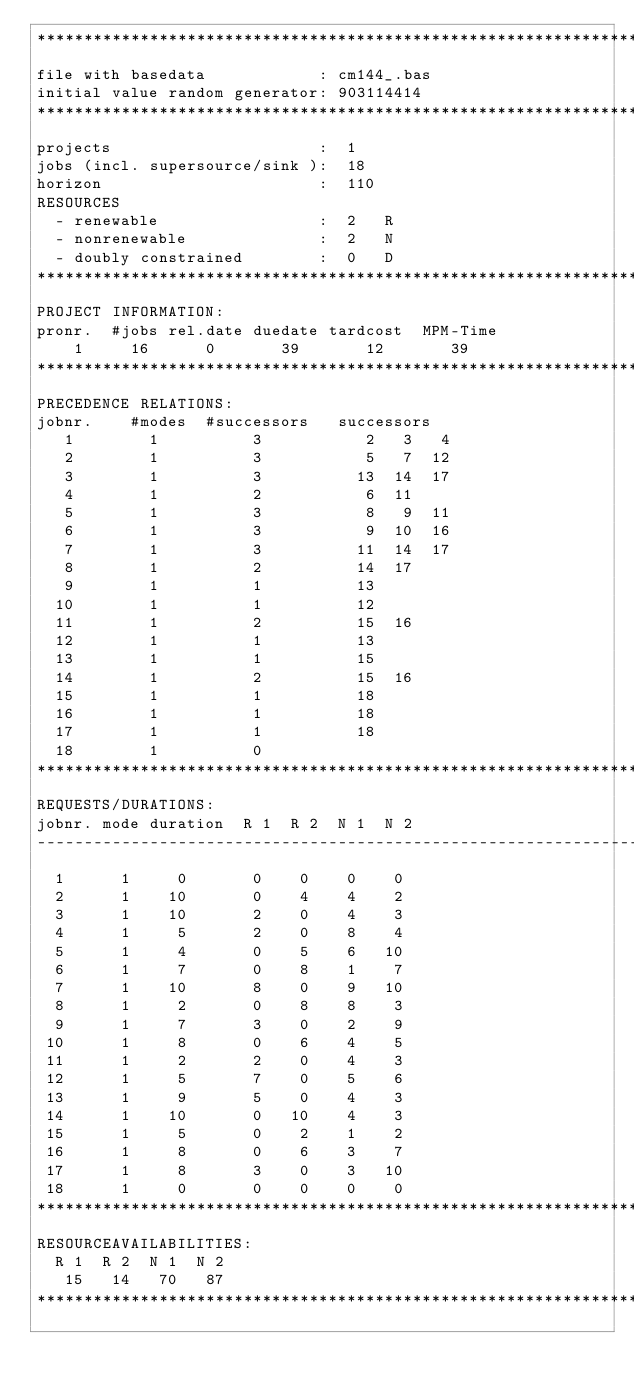<code> <loc_0><loc_0><loc_500><loc_500><_ObjectiveC_>************************************************************************
file with basedata            : cm144_.bas
initial value random generator: 903114414
************************************************************************
projects                      :  1
jobs (incl. supersource/sink ):  18
horizon                       :  110
RESOURCES
  - renewable                 :  2   R
  - nonrenewable              :  2   N
  - doubly constrained        :  0   D
************************************************************************
PROJECT INFORMATION:
pronr.  #jobs rel.date duedate tardcost  MPM-Time
    1     16      0       39       12       39
************************************************************************
PRECEDENCE RELATIONS:
jobnr.    #modes  #successors   successors
   1        1          3           2   3   4
   2        1          3           5   7  12
   3        1          3          13  14  17
   4        1          2           6  11
   5        1          3           8   9  11
   6        1          3           9  10  16
   7        1          3          11  14  17
   8        1          2          14  17
   9        1          1          13
  10        1          1          12
  11        1          2          15  16
  12        1          1          13
  13        1          1          15
  14        1          2          15  16
  15        1          1          18
  16        1          1          18
  17        1          1          18
  18        1          0        
************************************************************************
REQUESTS/DURATIONS:
jobnr. mode duration  R 1  R 2  N 1  N 2
------------------------------------------------------------------------
  1      1     0       0    0    0    0
  2      1    10       0    4    4    2
  3      1    10       2    0    4    3
  4      1     5       2    0    8    4
  5      1     4       0    5    6   10
  6      1     7       0    8    1    7
  7      1    10       8    0    9   10
  8      1     2       0    8    8    3
  9      1     7       3    0    2    9
 10      1     8       0    6    4    5
 11      1     2       2    0    4    3
 12      1     5       7    0    5    6
 13      1     9       5    0    4    3
 14      1    10       0   10    4    3
 15      1     5       0    2    1    2
 16      1     8       0    6    3    7
 17      1     8       3    0    3   10
 18      1     0       0    0    0    0
************************************************************************
RESOURCEAVAILABILITIES:
  R 1  R 2  N 1  N 2
   15   14   70   87
************************************************************************
</code> 